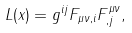Convert formula to latex. <formula><loc_0><loc_0><loc_500><loc_500>L ( x ) = g ^ { i j } F _ { \mu \nu , i } F _ { , j } ^ { \mu \nu } ,</formula> 